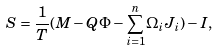Convert formula to latex. <formula><loc_0><loc_0><loc_500><loc_500>S = \frac { 1 } { T } ( M - Q \Phi - { { \sum _ { i = 1 } ^ { n } } } \Omega _ { i } J _ { i } ) - I ,</formula> 